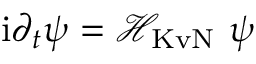Convert formula to latex. <formula><loc_0><loc_0><loc_500><loc_500>i \partial _ { t } \psi = \mathcal { H } _ { K v N } \psi</formula> 